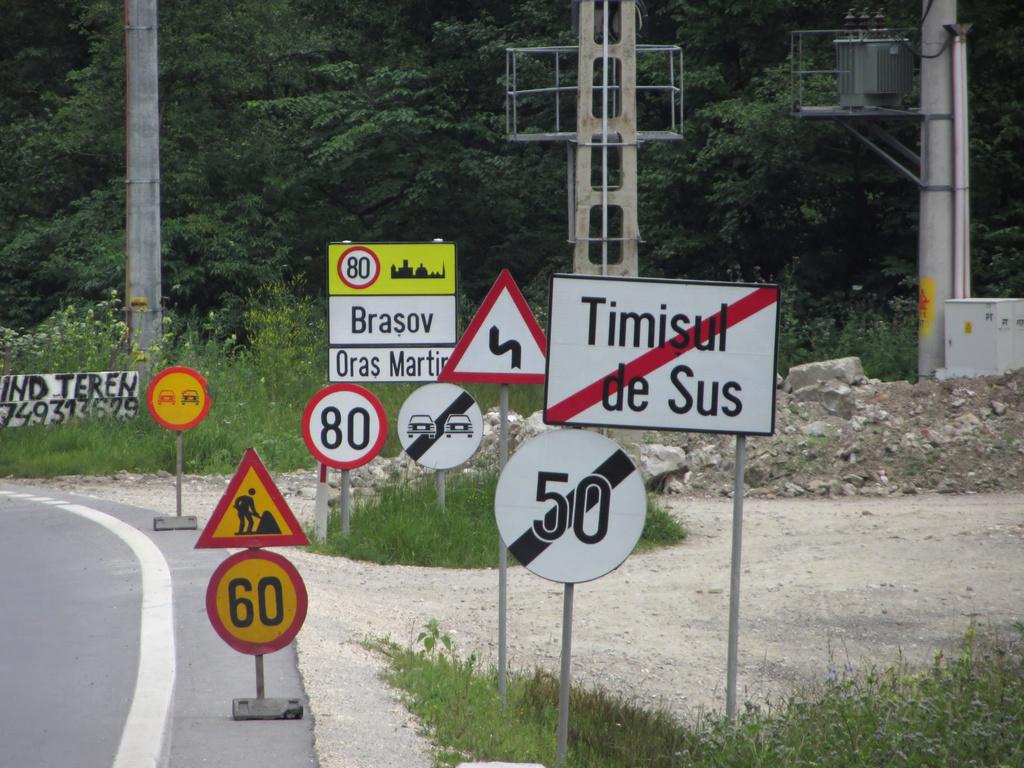What do the signs say?
Provide a short and direct response. Timisul de sus. What is the number on the yellow sign in the back?
Provide a short and direct response. 80. 